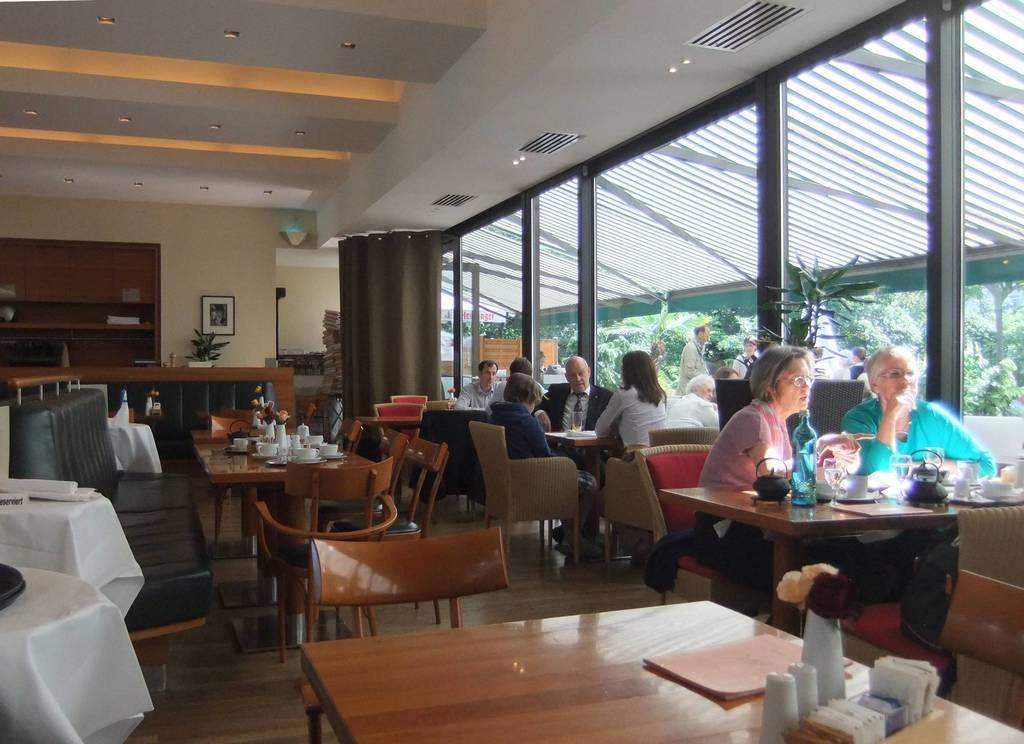Could you give a brief overview of what you see in this image? In this picture we can see a group of people sitting on chairs and in front of them on table we have book, tea pot, bottle, cup, saucer, glass and in background we can see window, some persons standing, sun shade, wall with frames, curtain. 